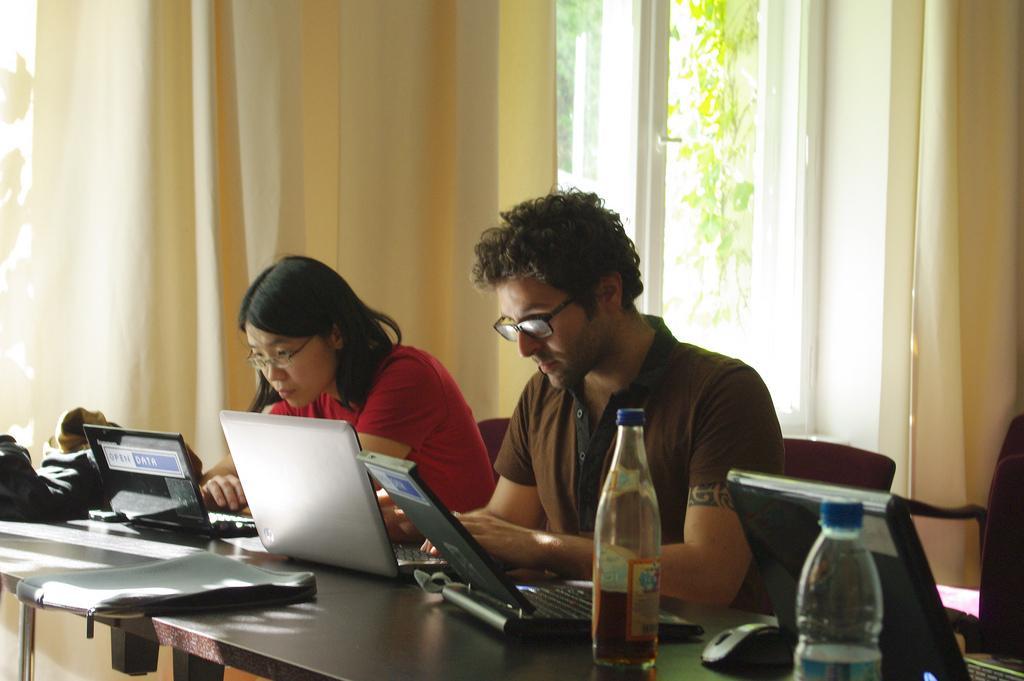Describe this image in one or two sentences. In this image there is one woman who is sitting. On the right side there is one man who is sitting and looking at laptop in front of them there is a table on the table there are some laptops and bottles and one mouse and some books are there. On the background there is a glass window and two curtains are there. 